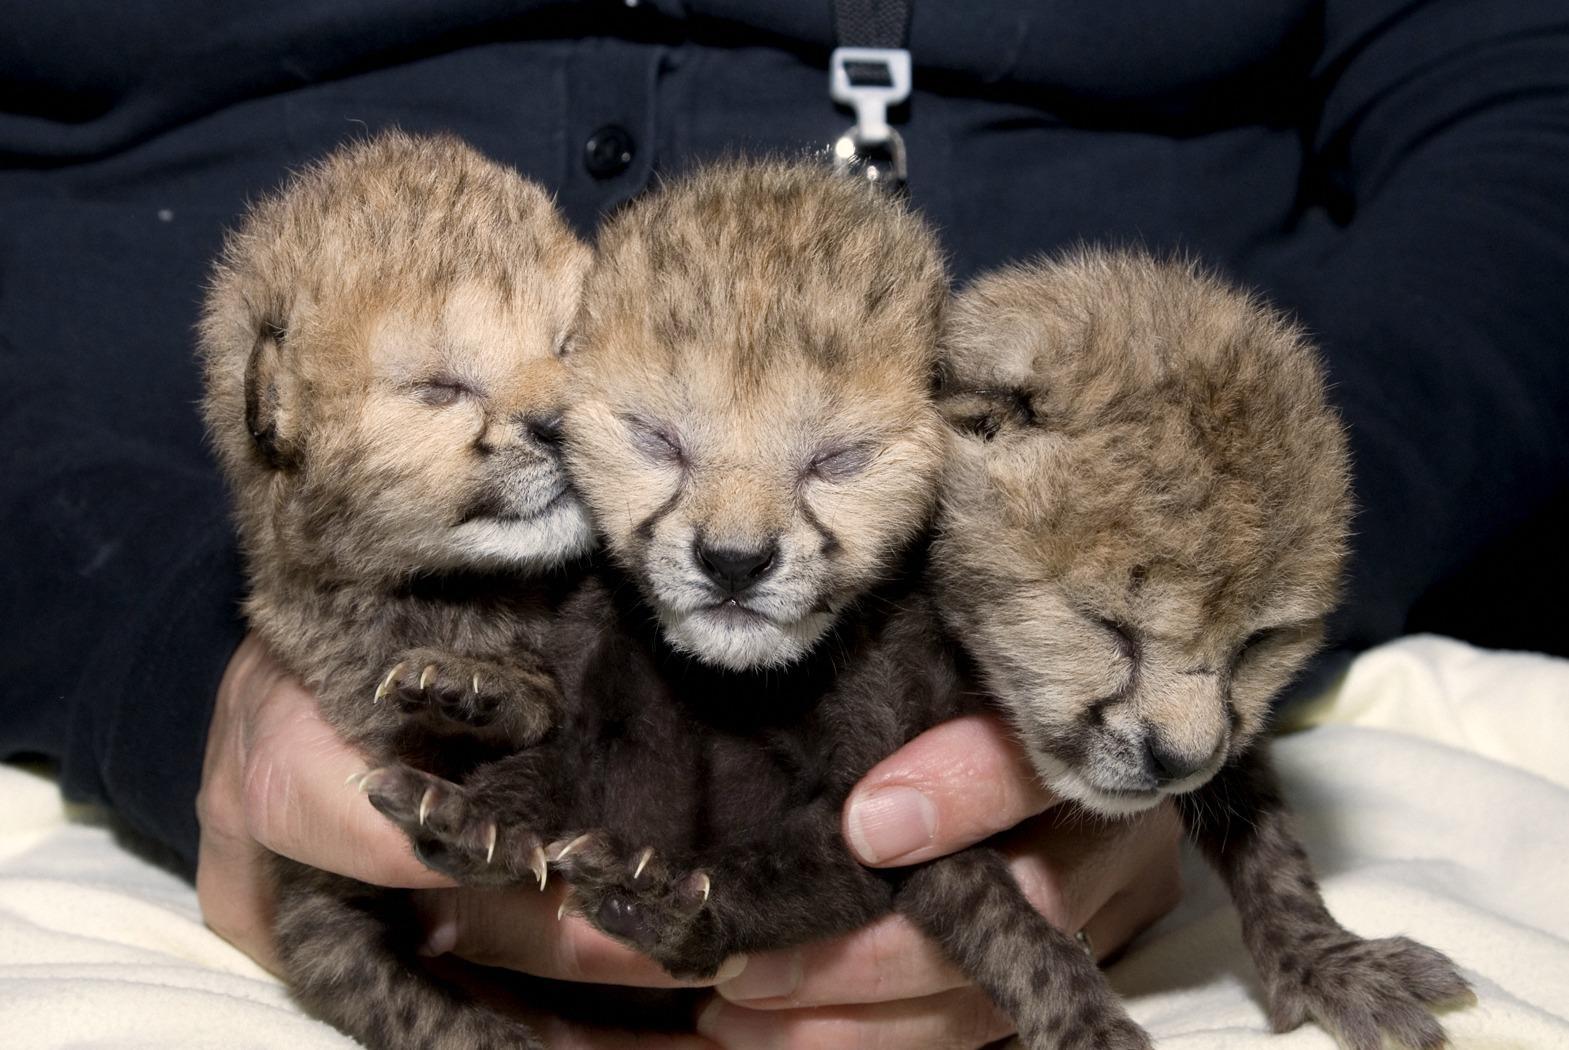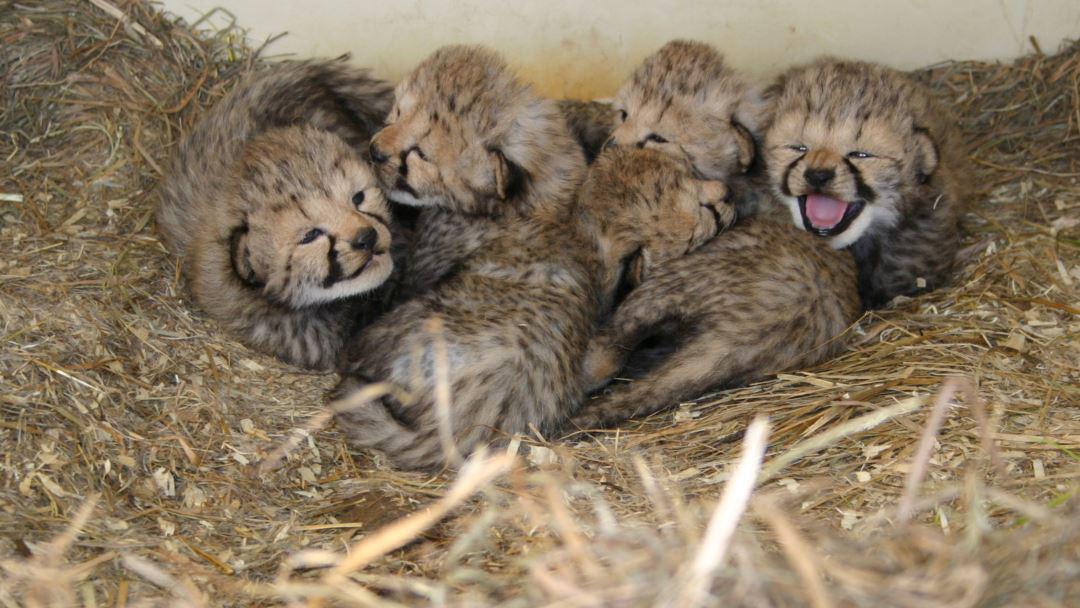The first image is the image on the left, the second image is the image on the right. Analyze the images presented: Is the assertion "In the image to the left, we see three kittens; the young of big cat breeds." valid? Answer yes or no. Yes. The first image is the image on the left, the second image is the image on the right. Examine the images to the left and right. Is the description "All of the animals shown are spotted wild kittens, and one image shows a group of wild kittens without fully open eyes in a pile on straw." accurate? Answer yes or no. Yes. 